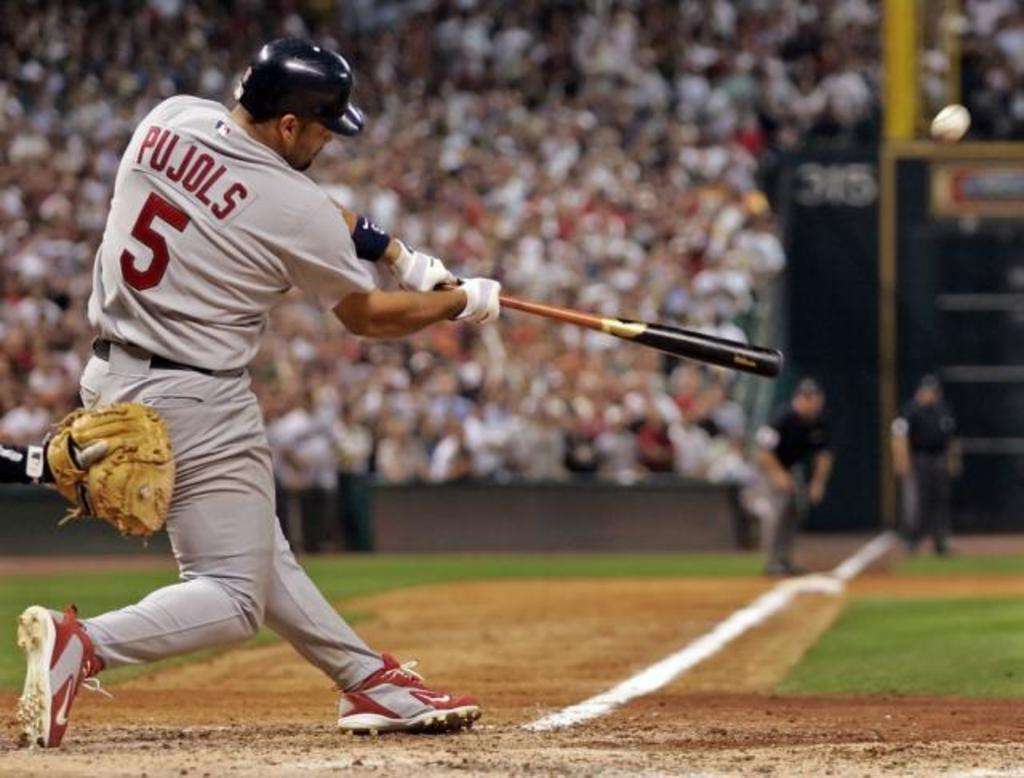<image>
Describe the image concisely. A baseball player with a number 5 jersey hits a baseball. 